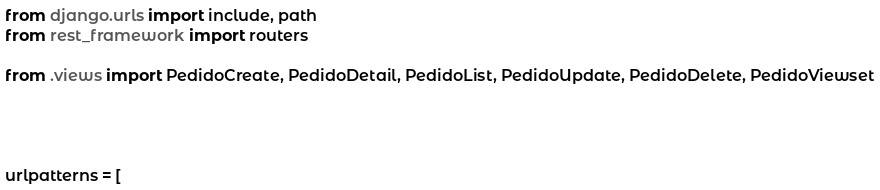<code> <loc_0><loc_0><loc_500><loc_500><_Python_>from django.urls import include, path
from rest_framework import routers

from .views import PedidoCreate, PedidoDetail, PedidoList, PedidoUpdate, PedidoDelete, PedidoViewset




urlpatterns = [
</code> 